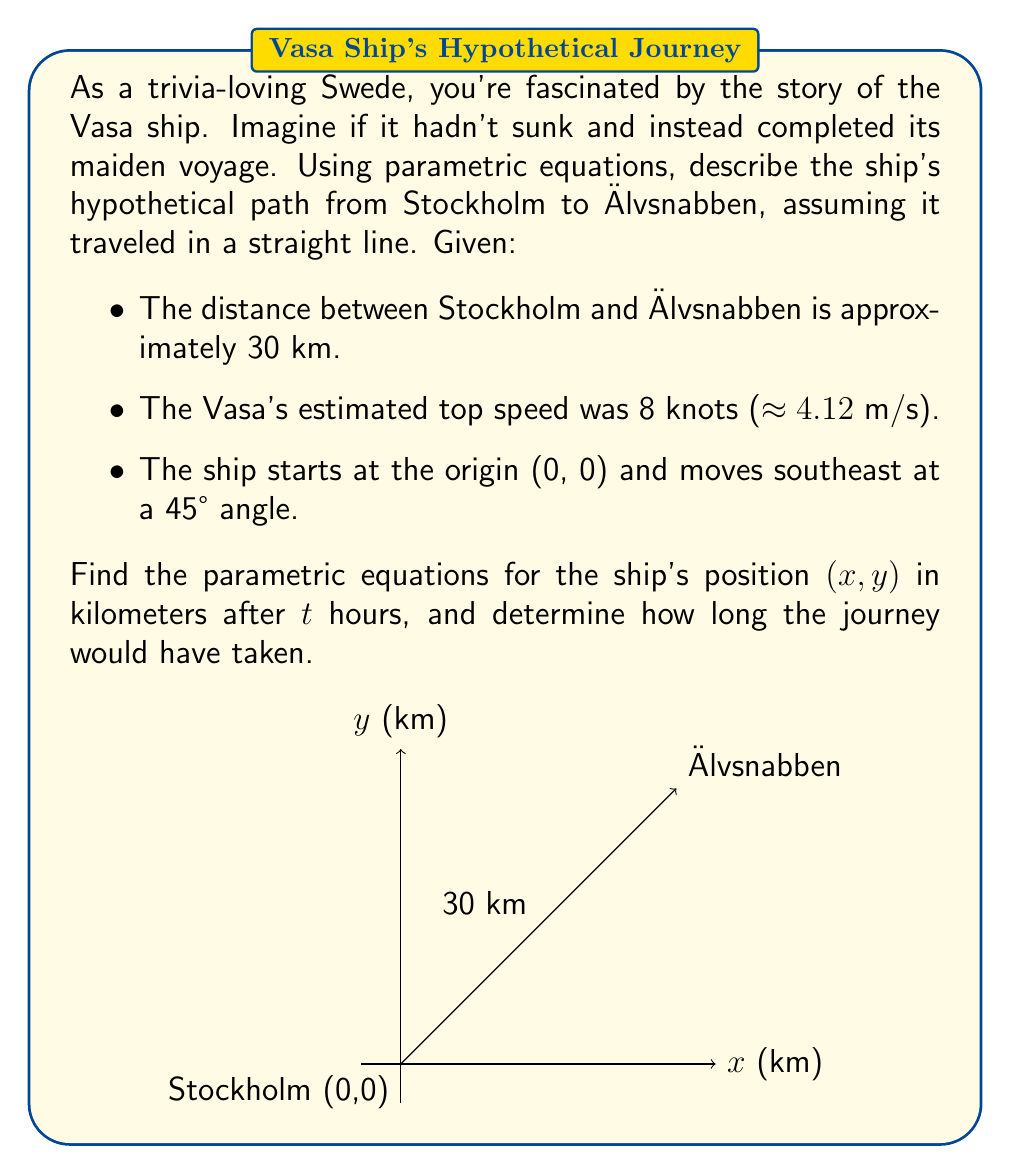Show me your answer to this math problem. Let's approach this step-by-step:

1) First, we need to convert the ship's speed to km/h:
   $4.12 \text{ m/s} \times 3600 \text{ s/h} \times \frac{1 \text{ km}}{1000 \text{ m}} = 14.832 \text{ km/h}$

2) The ship is moving at a 45° angle, so its velocity can be split equally between x and y components:
   $v_x = v_y = \frac{14.832}{\sqrt{2}} \approx 10.488 \text{ km/h}$

3) Now we can write the parametric equations:
   $$x(t) = 10.488t$$
   $$y(t) = 10.488t$$
   Where t is time in hours.

4) To find the journey time, we use the Pythagorean theorem:
   $30^2 = x^2 + y^2 = (10.488t)^2 + (10.488t)^2 = 2(10.488t)^2$

5) Solve for t:
   $900 = 2(110.0)t^2$
   $t^2 = \frac{900}{220.0} = 4.091$
   $t = \sqrt{4.091} \approx 2.023 \text{ hours}$

Therefore, the journey would have taken approximately 2.023 hours or 2 hours and 1.4 minutes.
Answer: $x(t) = 10.488t$, $y(t) = 10.488t$, journey time ≈ 2.023 hours 